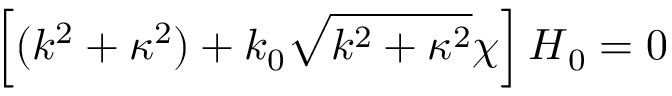Convert formula to latex. <formula><loc_0><loc_0><loc_500><loc_500>\left [ ( k ^ { 2 } + \kappa ^ { 2 } ) + k _ { 0 } \sqrt { k ^ { 2 } + \kappa ^ { 2 } } \chi \right ] { H } _ { 0 } = 0</formula> 